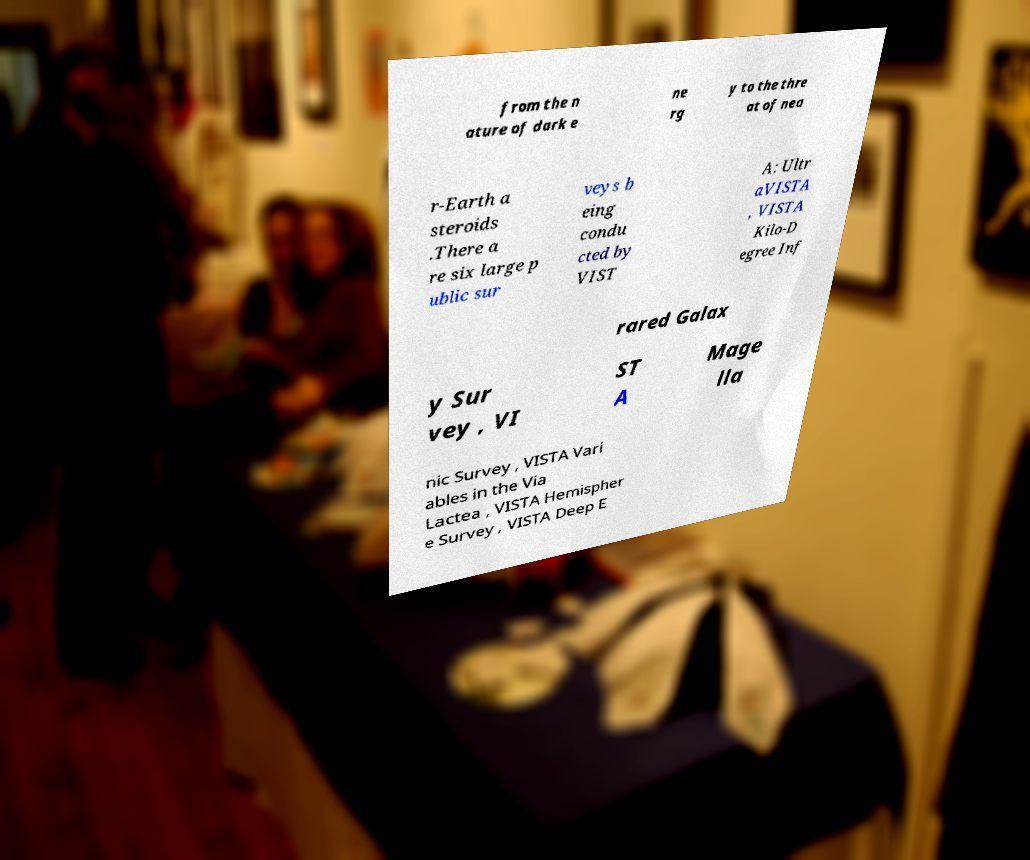I need the written content from this picture converted into text. Can you do that? from the n ature of dark e ne rg y to the thre at of nea r-Earth a steroids .There a re six large p ublic sur veys b eing condu cted by VIST A: Ultr aVISTA , VISTA Kilo-D egree Inf rared Galax y Sur vey , VI ST A Mage lla nic Survey , VISTA Vari ables in the Via Lactea , VISTA Hemispher e Survey , VISTA Deep E 